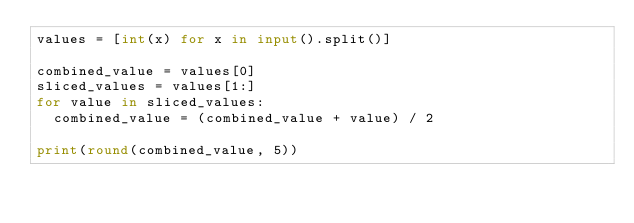Convert code to text. <code><loc_0><loc_0><loc_500><loc_500><_Python_>values = [int(x) for x in input().split()]

combined_value = values[0]
sliced_values = values[1:]
for value in sliced_values:
  combined_value = (combined_value + value) / 2

print(round(combined_value, 5))</code> 